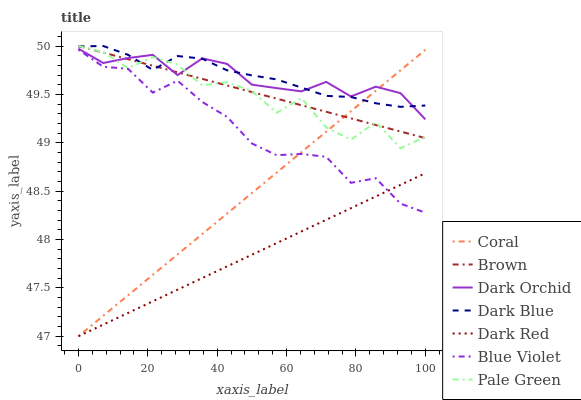Does Dark Red have the minimum area under the curve?
Answer yes or no. Yes. Does Dark Blue have the maximum area under the curve?
Answer yes or no. Yes. Does Coral have the minimum area under the curve?
Answer yes or no. No. Does Coral have the maximum area under the curve?
Answer yes or no. No. Is Dark Red the smoothest?
Answer yes or no. Yes. Is Pale Green the roughest?
Answer yes or no. Yes. Is Coral the smoothest?
Answer yes or no. No. Is Coral the roughest?
Answer yes or no. No. Does Dark Red have the lowest value?
Answer yes or no. Yes. Does Dark Orchid have the lowest value?
Answer yes or no. No. Does Pale Green have the highest value?
Answer yes or no. Yes. Does Coral have the highest value?
Answer yes or no. No. Is Dark Red less than Brown?
Answer yes or no. Yes. Is Dark Blue greater than Blue Violet?
Answer yes or no. Yes. Does Dark Red intersect Coral?
Answer yes or no. Yes. Is Dark Red less than Coral?
Answer yes or no. No. Is Dark Red greater than Coral?
Answer yes or no. No. Does Dark Red intersect Brown?
Answer yes or no. No. 